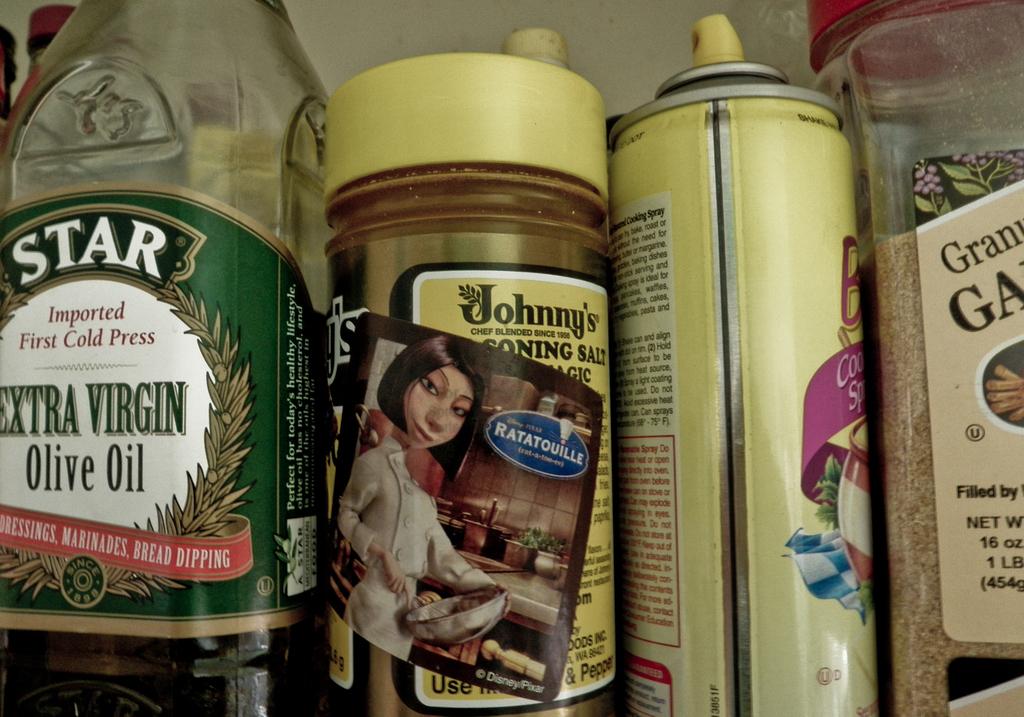Which kind of oil is the green one on the left?
Ensure brevity in your answer.  Extra virgin olive oil. 